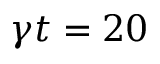<formula> <loc_0><loc_0><loc_500><loc_500>\gamma t = 2 0</formula> 